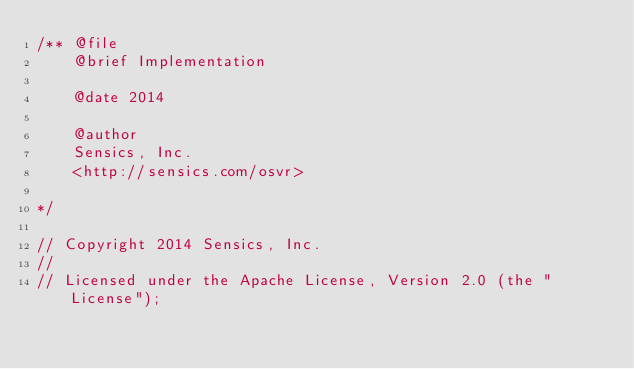Convert code to text. <code><loc_0><loc_0><loc_500><loc_500><_C++_>/** @file
    @brief Implementation

    @date 2014

    @author
    Sensics, Inc.
    <http://sensics.com/osvr>

*/

// Copyright 2014 Sensics, Inc.
//
// Licensed under the Apache License, Version 2.0 (the "License");</code> 